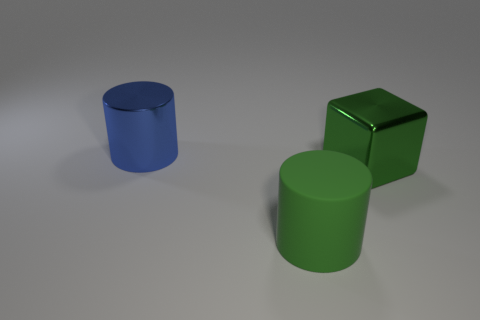Add 2 large blue rubber blocks. How many objects exist? 5 Subtract all cubes. How many objects are left? 2 Subtract all small purple rubber balls. Subtract all cubes. How many objects are left? 2 Add 3 blue shiny things. How many blue shiny things are left? 4 Add 2 matte cylinders. How many matte cylinders exist? 3 Subtract 0 yellow blocks. How many objects are left? 3 